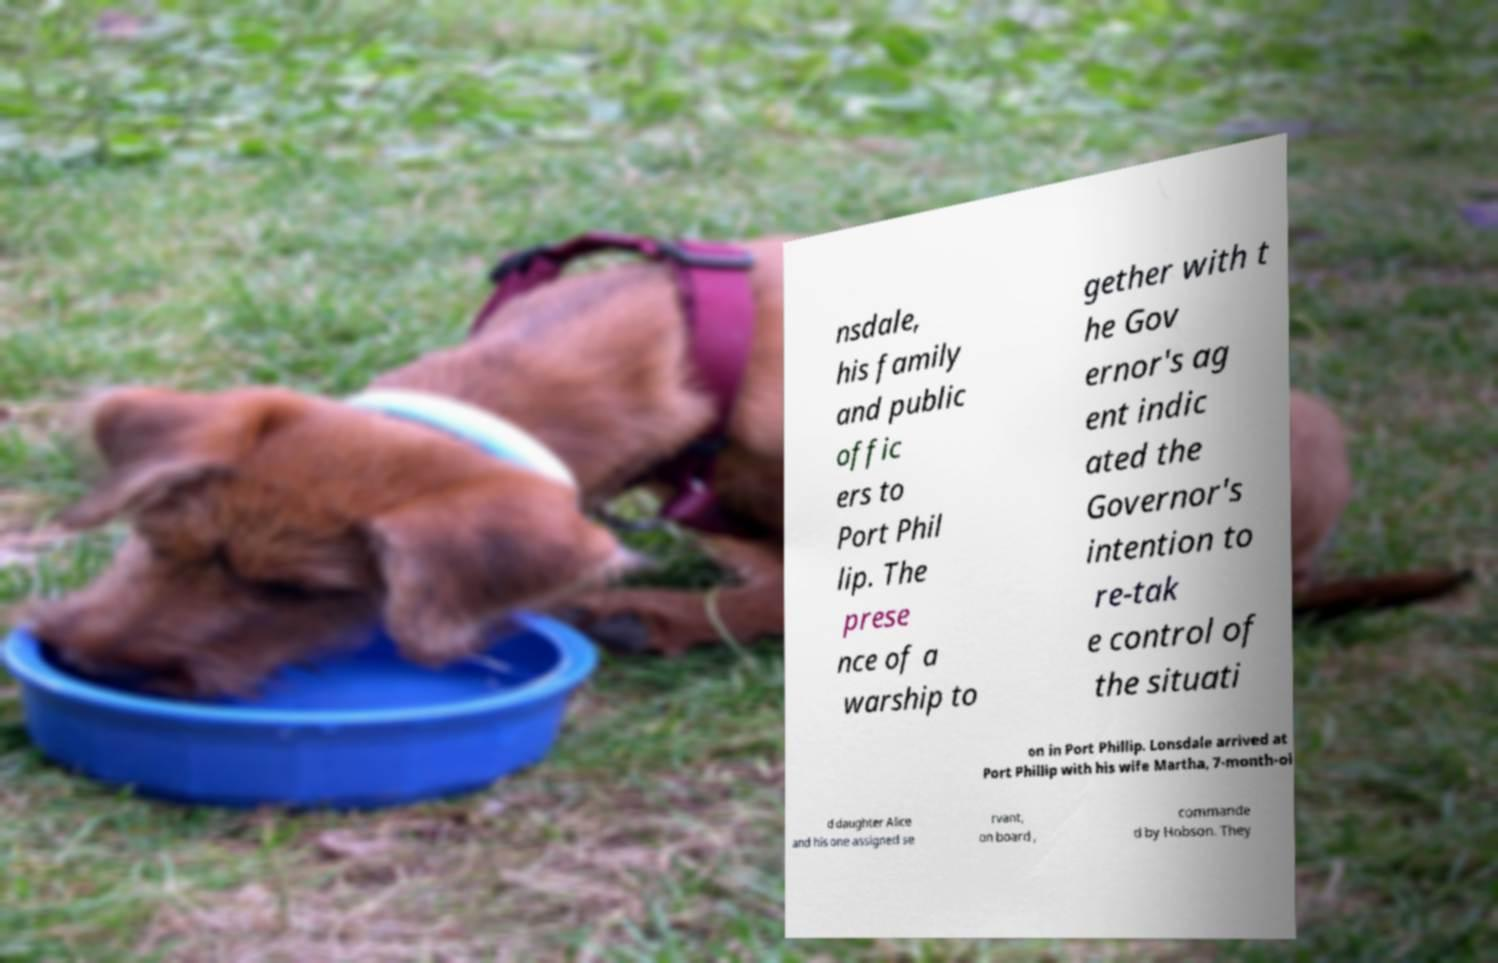There's text embedded in this image that I need extracted. Can you transcribe it verbatim? nsdale, his family and public offic ers to Port Phil lip. The prese nce of a warship to gether with t he Gov ernor's ag ent indic ated the Governor's intention to re-tak e control of the situati on in Port Phillip. Lonsdale arrived at Port Phillip with his wife Martha, 7-month-ol d daughter Alice and his one assigned se rvant, on board , commande d by Hobson. They 